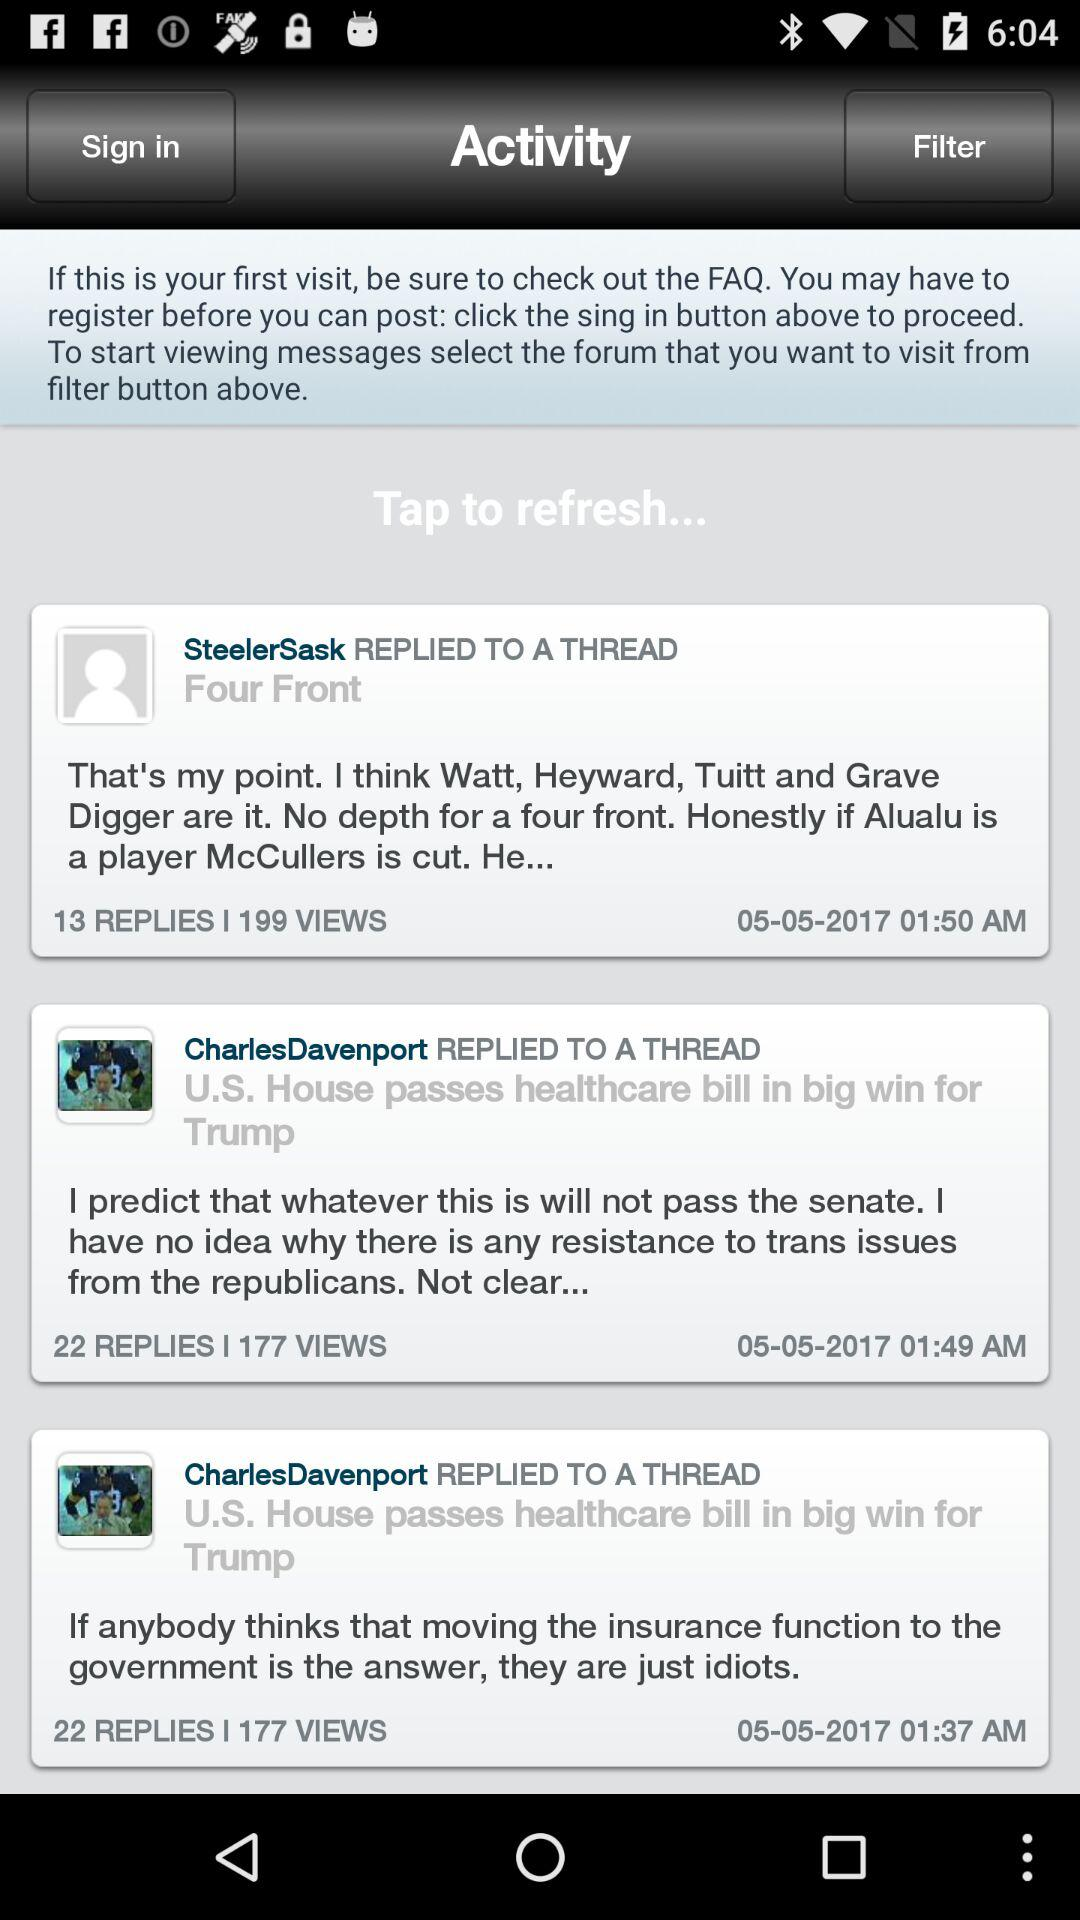How many replies are there for the second most recent post?
Answer the question using a single word or phrase. 22 